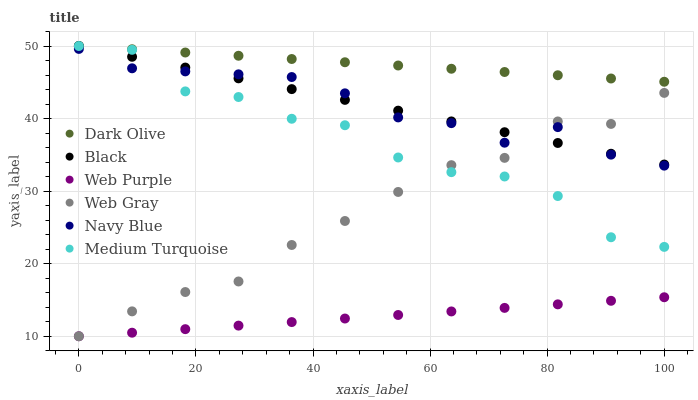Does Web Purple have the minimum area under the curve?
Answer yes or no. Yes. Does Dark Olive have the maximum area under the curve?
Answer yes or no. Yes. Does Navy Blue have the minimum area under the curve?
Answer yes or no. No. Does Navy Blue have the maximum area under the curve?
Answer yes or no. No. Is Web Purple the smoothest?
Answer yes or no. Yes. Is Medium Turquoise the roughest?
Answer yes or no. Yes. Is Navy Blue the smoothest?
Answer yes or no. No. Is Navy Blue the roughest?
Answer yes or no. No. Does Web Gray have the lowest value?
Answer yes or no. Yes. Does Navy Blue have the lowest value?
Answer yes or no. No. Does Medium Turquoise have the highest value?
Answer yes or no. Yes. Does Navy Blue have the highest value?
Answer yes or no. No. Is Web Purple less than Medium Turquoise?
Answer yes or no. Yes. Is Medium Turquoise greater than Web Purple?
Answer yes or no. Yes. Does Web Gray intersect Web Purple?
Answer yes or no. Yes. Is Web Gray less than Web Purple?
Answer yes or no. No. Is Web Gray greater than Web Purple?
Answer yes or no. No. Does Web Purple intersect Medium Turquoise?
Answer yes or no. No. 